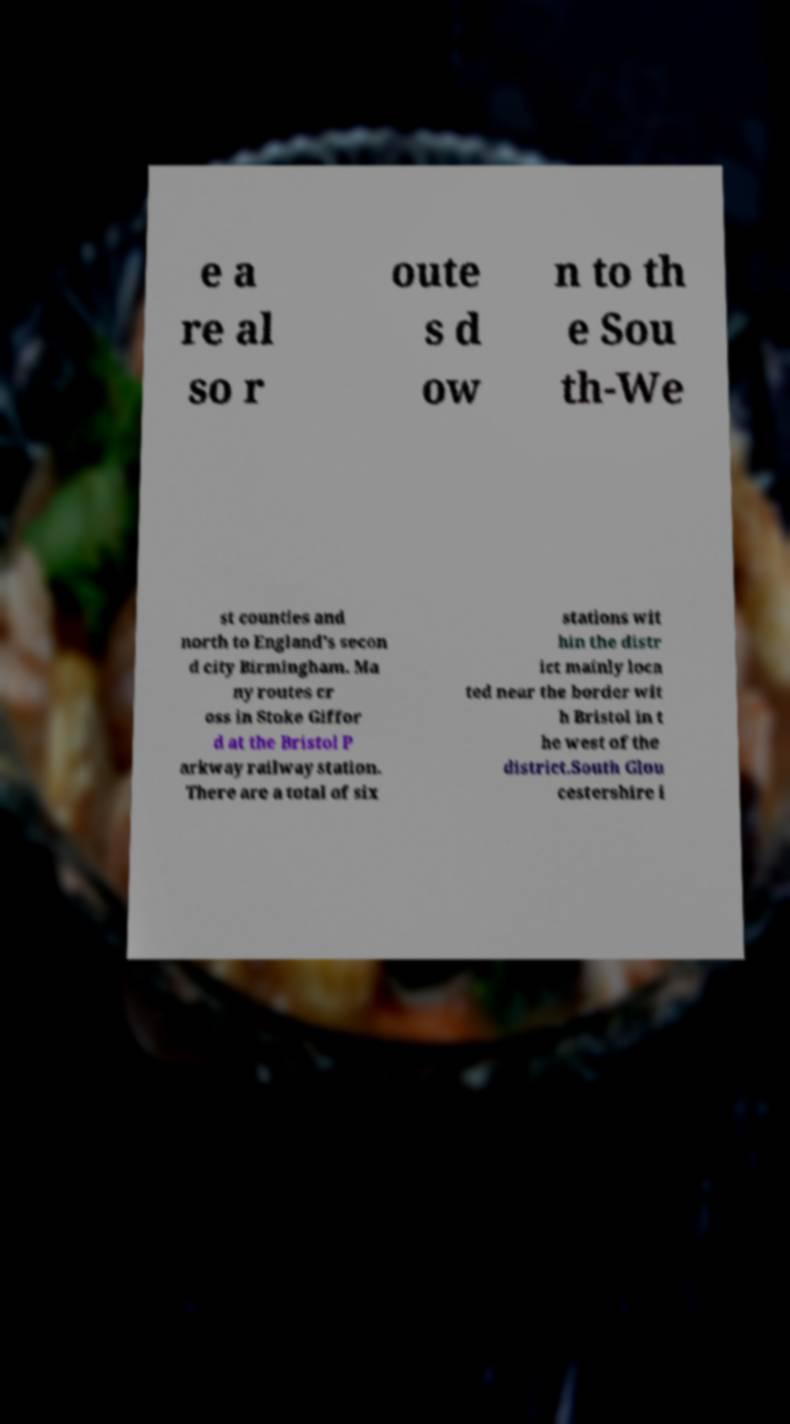Please identify and transcribe the text found in this image. e a re al so r oute s d ow n to th e Sou th-We st counties and north to England's secon d city Birmingham. Ma ny routes cr oss in Stoke Giffor d at the Bristol P arkway railway station. There are a total of six stations wit hin the distr ict mainly loca ted near the border wit h Bristol in t he west of the district.South Glou cestershire i 